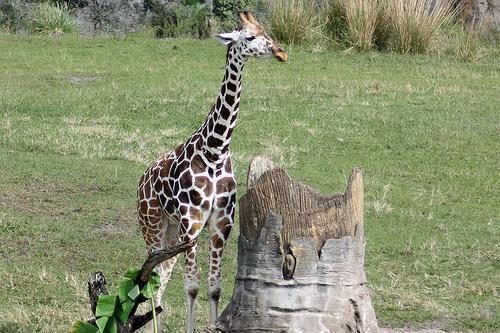How many giraffes?
Give a very brief answer. 1. 